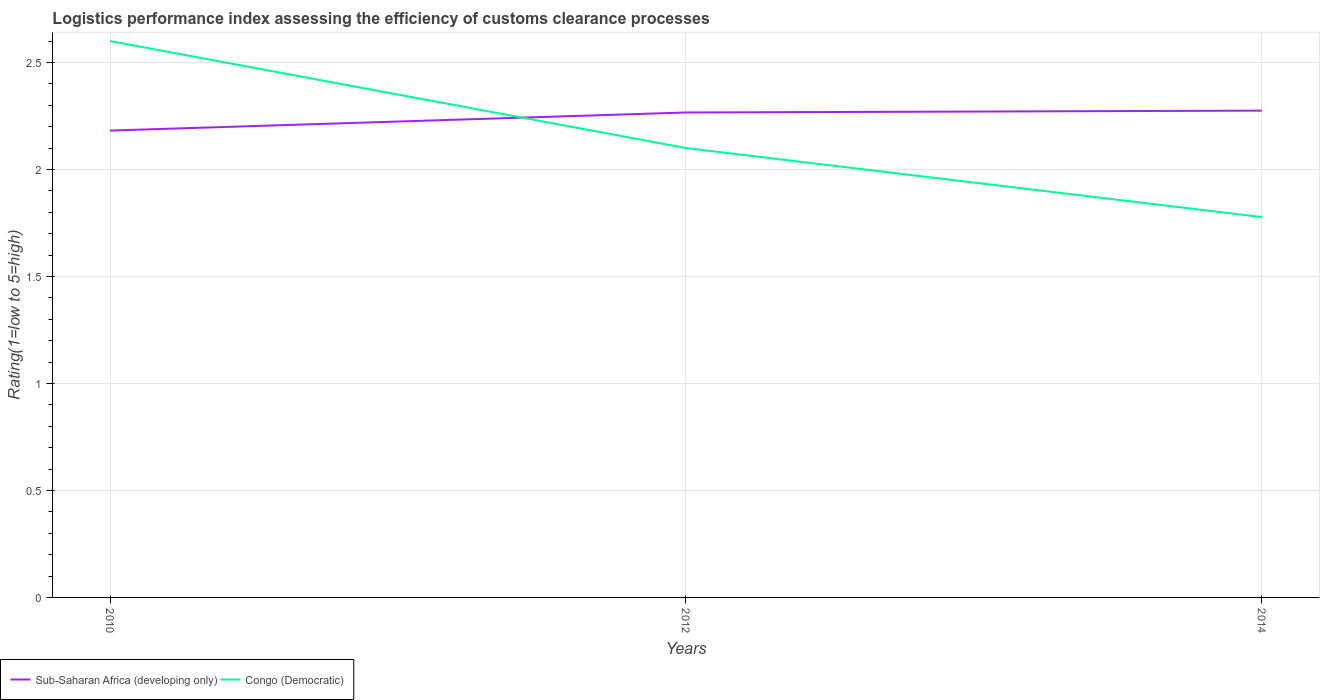Does the line corresponding to Congo (Democratic) intersect with the line corresponding to Sub-Saharan Africa (developing only)?
Your response must be concise. Yes. Is the number of lines equal to the number of legend labels?
Provide a succinct answer. Yes. Across all years, what is the maximum Logistic performance index in Sub-Saharan Africa (developing only)?
Offer a very short reply. 2.18. In which year was the Logistic performance index in Congo (Democratic) maximum?
Provide a short and direct response. 2014. What is the total Logistic performance index in Sub-Saharan Africa (developing only) in the graph?
Ensure brevity in your answer.  -0.09. What is the difference between the highest and the second highest Logistic performance index in Congo (Democratic)?
Your answer should be compact. 0.82. What is the difference between the highest and the lowest Logistic performance index in Sub-Saharan Africa (developing only)?
Provide a succinct answer. 2. Is the Logistic performance index in Congo (Democratic) strictly greater than the Logistic performance index in Sub-Saharan Africa (developing only) over the years?
Give a very brief answer. No. How many lines are there?
Make the answer very short. 2. Does the graph contain any zero values?
Make the answer very short. No. How are the legend labels stacked?
Ensure brevity in your answer.  Horizontal. What is the title of the graph?
Provide a succinct answer. Logistics performance index assessing the efficiency of customs clearance processes. Does "Benin" appear as one of the legend labels in the graph?
Provide a short and direct response. No. What is the label or title of the Y-axis?
Your answer should be very brief. Rating(1=low to 5=high). What is the Rating(1=low to 5=high) of Sub-Saharan Africa (developing only) in 2010?
Provide a short and direct response. 2.18. What is the Rating(1=low to 5=high) of Congo (Democratic) in 2010?
Your response must be concise. 2.6. What is the Rating(1=low to 5=high) in Sub-Saharan Africa (developing only) in 2012?
Offer a terse response. 2.27. What is the Rating(1=low to 5=high) in Sub-Saharan Africa (developing only) in 2014?
Your answer should be very brief. 2.27. What is the Rating(1=low to 5=high) in Congo (Democratic) in 2014?
Provide a succinct answer. 1.78. Across all years, what is the maximum Rating(1=low to 5=high) in Sub-Saharan Africa (developing only)?
Give a very brief answer. 2.27. Across all years, what is the minimum Rating(1=low to 5=high) in Sub-Saharan Africa (developing only)?
Your response must be concise. 2.18. Across all years, what is the minimum Rating(1=low to 5=high) in Congo (Democratic)?
Provide a succinct answer. 1.78. What is the total Rating(1=low to 5=high) of Sub-Saharan Africa (developing only) in the graph?
Offer a terse response. 6.72. What is the total Rating(1=low to 5=high) of Congo (Democratic) in the graph?
Your response must be concise. 6.48. What is the difference between the Rating(1=low to 5=high) in Sub-Saharan Africa (developing only) in 2010 and that in 2012?
Your answer should be very brief. -0.08. What is the difference between the Rating(1=low to 5=high) of Sub-Saharan Africa (developing only) in 2010 and that in 2014?
Your response must be concise. -0.09. What is the difference between the Rating(1=low to 5=high) of Congo (Democratic) in 2010 and that in 2014?
Your response must be concise. 0.82. What is the difference between the Rating(1=low to 5=high) of Sub-Saharan Africa (developing only) in 2012 and that in 2014?
Your answer should be very brief. -0.01. What is the difference between the Rating(1=low to 5=high) of Congo (Democratic) in 2012 and that in 2014?
Give a very brief answer. 0.32. What is the difference between the Rating(1=low to 5=high) in Sub-Saharan Africa (developing only) in 2010 and the Rating(1=low to 5=high) in Congo (Democratic) in 2012?
Ensure brevity in your answer.  0.08. What is the difference between the Rating(1=low to 5=high) of Sub-Saharan Africa (developing only) in 2010 and the Rating(1=low to 5=high) of Congo (Democratic) in 2014?
Keep it short and to the point. 0.4. What is the difference between the Rating(1=low to 5=high) in Sub-Saharan Africa (developing only) in 2012 and the Rating(1=low to 5=high) in Congo (Democratic) in 2014?
Ensure brevity in your answer.  0.49. What is the average Rating(1=low to 5=high) of Sub-Saharan Africa (developing only) per year?
Keep it short and to the point. 2.24. What is the average Rating(1=low to 5=high) in Congo (Democratic) per year?
Your answer should be very brief. 2.16. In the year 2010, what is the difference between the Rating(1=low to 5=high) in Sub-Saharan Africa (developing only) and Rating(1=low to 5=high) in Congo (Democratic)?
Offer a very short reply. -0.42. In the year 2012, what is the difference between the Rating(1=low to 5=high) of Sub-Saharan Africa (developing only) and Rating(1=low to 5=high) of Congo (Democratic)?
Keep it short and to the point. 0.17. In the year 2014, what is the difference between the Rating(1=low to 5=high) of Sub-Saharan Africa (developing only) and Rating(1=low to 5=high) of Congo (Democratic)?
Offer a terse response. 0.5. What is the ratio of the Rating(1=low to 5=high) in Sub-Saharan Africa (developing only) in 2010 to that in 2012?
Give a very brief answer. 0.96. What is the ratio of the Rating(1=low to 5=high) of Congo (Democratic) in 2010 to that in 2012?
Your answer should be very brief. 1.24. What is the ratio of the Rating(1=low to 5=high) in Congo (Democratic) in 2010 to that in 2014?
Offer a terse response. 1.46. What is the ratio of the Rating(1=low to 5=high) in Sub-Saharan Africa (developing only) in 2012 to that in 2014?
Ensure brevity in your answer.  1. What is the ratio of the Rating(1=low to 5=high) in Congo (Democratic) in 2012 to that in 2014?
Keep it short and to the point. 1.18. What is the difference between the highest and the second highest Rating(1=low to 5=high) of Sub-Saharan Africa (developing only)?
Offer a very short reply. 0.01. What is the difference between the highest and the lowest Rating(1=low to 5=high) in Sub-Saharan Africa (developing only)?
Your answer should be very brief. 0.09. What is the difference between the highest and the lowest Rating(1=low to 5=high) of Congo (Democratic)?
Keep it short and to the point. 0.82. 